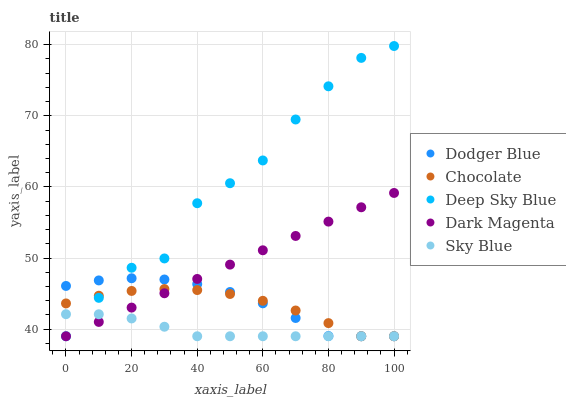Does Sky Blue have the minimum area under the curve?
Answer yes or no. Yes. Does Deep Sky Blue have the maximum area under the curve?
Answer yes or no. Yes. Does Dodger Blue have the minimum area under the curve?
Answer yes or no. No. Does Dodger Blue have the maximum area under the curve?
Answer yes or no. No. Is Dark Magenta the smoothest?
Answer yes or no. Yes. Is Deep Sky Blue the roughest?
Answer yes or no. Yes. Is Dodger Blue the smoothest?
Answer yes or no. No. Is Dodger Blue the roughest?
Answer yes or no. No. Does Sky Blue have the lowest value?
Answer yes or no. Yes. Does Deep Sky Blue have the highest value?
Answer yes or no. Yes. Does Dodger Blue have the highest value?
Answer yes or no. No. Does Chocolate intersect Deep Sky Blue?
Answer yes or no. Yes. Is Chocolate less than Deep Sky Blue?
Answer yes or no. No. Is Chocolate greater than Deep Sky Blue?
Answer yes or no. No. 